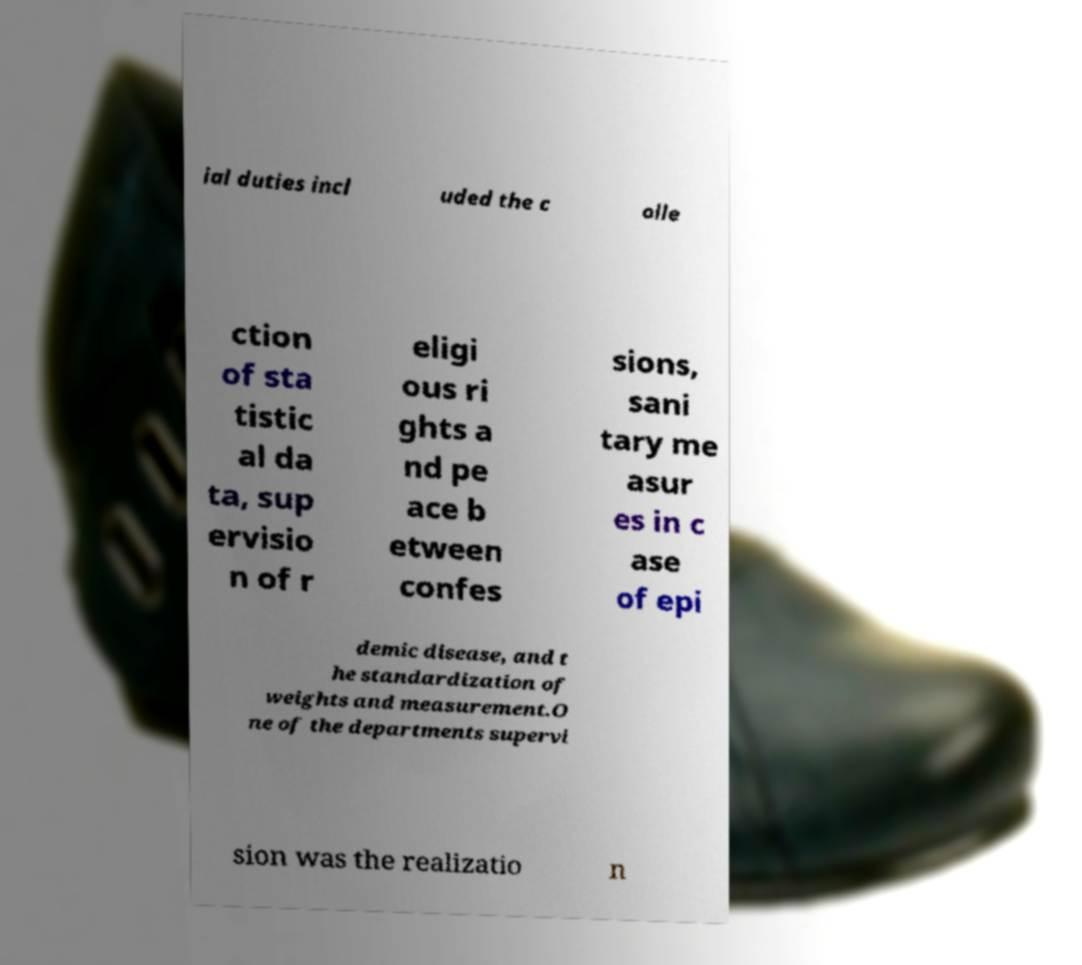I need the written content from this picture converted into text. Can you do that? ial duties incl uded the c olle ction of sta tistic al da ta, sup ervisio n of r eligi ous ri ghts a nd pe ace b etween confes sions, sani tary me asur es in c ase of epi demic disease, and t he standardization of weights and measurement.O ne of the departments supervi sion was the realizatio n 